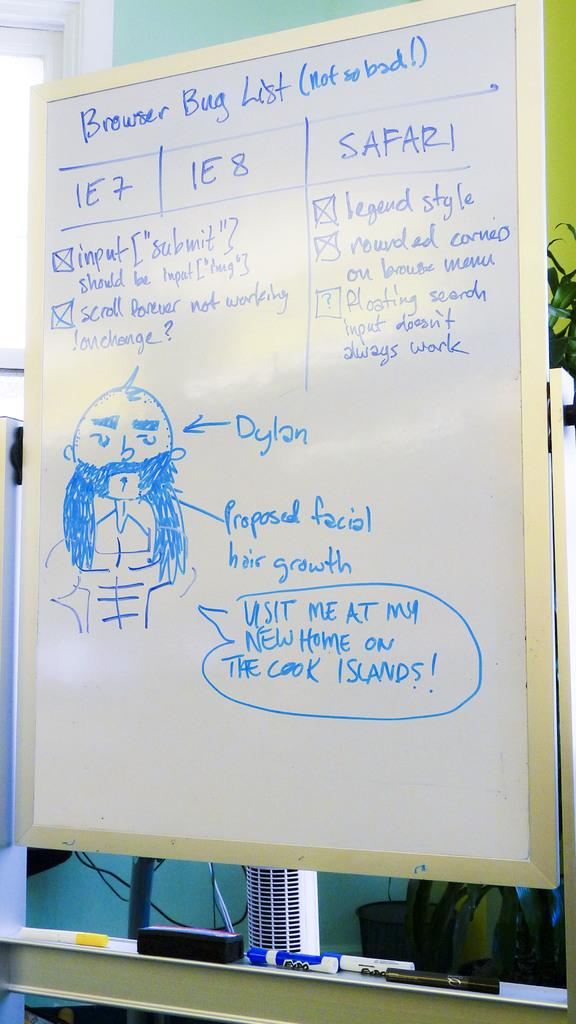Provide a one-sentence caption for the provided image. Someone has drawn a picture of Dylan on the board and labeled it. 